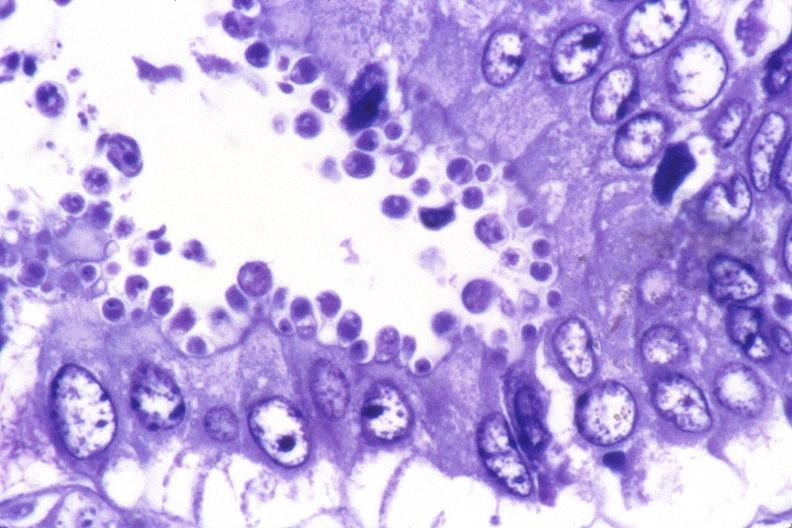what does this image show?
Answer the question using a single word or phrase. Colon 